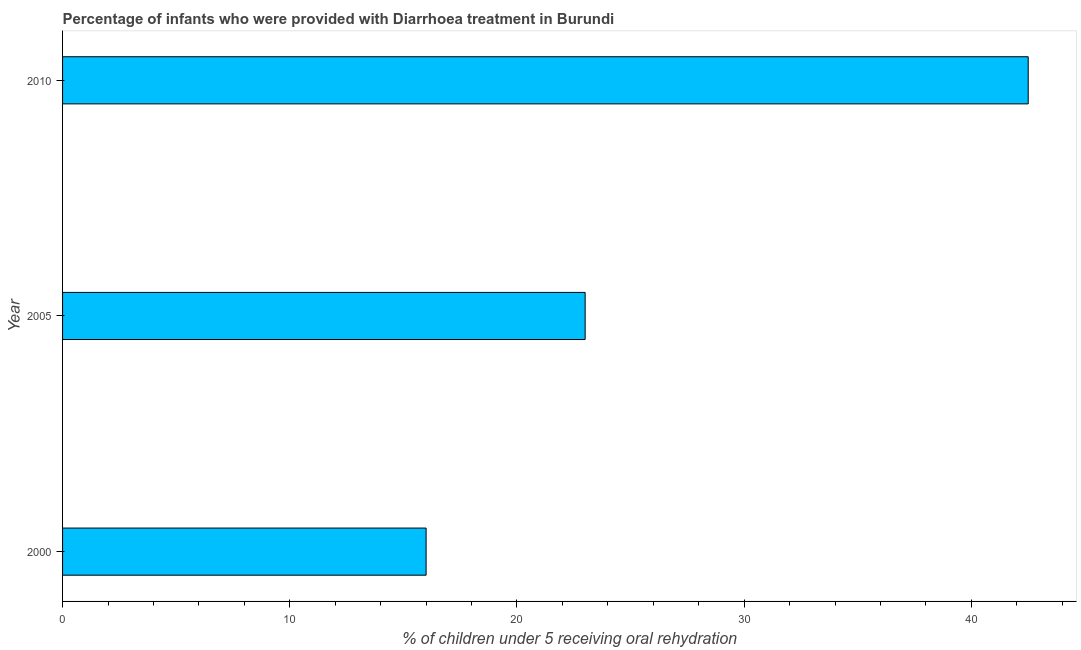Does the graph contain any zero values?
Your answer should be very brief. No. What is the title of the graph?
Keep it short and to the point. Percentage of infants who were provided with Diarrhoea treatment in Burundi. What is the label or title of the X-axis?
Offer a very short reply. % of children under 5 receiving oral rehydration. What is the label or title of the Y-axis?
Your response must be concise. Year. What is the percentage of children who were provided with treatment diarrhoea in 2005?
Give a very brief answer. 23. Across all years, what is the maximum percentage of children who were provided with treatment diarrhoea?
Your answer should be compact. 42.5. In which year was the percentage of children who were provided with treatment diarrhoea maximum?
Keep it short and to the point. 2010. In which year was the percentage of children who were provided with treatment diarrhoea minimum?
Your response must be concise. 2000. What is the sum of the percentage of children who were provided with treatment diarrhoea?
Offer a terse response. 81.5. What is the difference between the percentage of children who were provided with treatment diarrhoea in 2005 and 2010?
Offer a terse response. -19.5. What is the average percentage of children who were provided with treatment diarrhoea per year?
Your answer should be very brief. 27.17. In how many years, is the percentage of children who were provided with treatment diarrhoea greater than 34 %?
Provide a short and direct response. 1. Do a majority of the years between 2010 and 2005 (inclusive) have percentage of children who were provided with treatment diarrhoea greater than 26 %?
Ensure brevity in your answer.  No. What is the ratio of the percentage of children who were provided with treatment diarrhoea in 2005 to that in 2010?
Make the answer very short. 0.54. Is the difference between the percentage of children who were provided with treatment diarrhoea in 2005 and 2010 greater than the difference between any two years?
Your response must be concise. No. Is the sum of the percentage of children who were provided with treatment diarrhoea in 2000 and 2010 greater than the maximum percentage of children who were provided with treatment diarrhoea across all years?
Provide a succinct answer. Yes. What is the difference between the highest and the lowest percentage of children who were provided with treatment diarrhoea?
Provide a succinct answer. 26.5. How many bars are there?
Give a very brief answer. 3. Are all the bars in the graph horizontal?
Offer a very short reply. Yes. How many years are there in the graph?
Your answer should be very brief. 3. What is the difference between two consecutive major ticks on the X-axis?
Keep it short and to the point. 10. What is the % of children under 5 receiving oral rehydration of 2000?
Offer a terse response. 16. What is the % of children under 5 receiving oral rehydration of 2005?
Offer a terse response. 23. What is the % of children under 5 receiving oral rehydration of 2010?
Offer a terse response. 42.5. What is the difference between the % of children under 5 receiving oral rehydration in 2000 and 2010?
Offer a very short reply. -26.5. What is the difference between the % of children under 5 receiving oral rehydration in 2005 and 2010?
Ensure brevity in your answer.  -19.5. What is the ratio of the % of children under 5 receiving oral rehydration in 2000 to that in 2005?
Offer a terse response. 0.7. What is the ratio of the % of children under 5 receiving oral rehydration in 2000 to that in 2010?
Offer a very short reply. 0.38. What is the ratio of the % of children under 5 receiving oral rehydration in 2005 to that in 2010?
Provide a short and direct response. 0.54. 